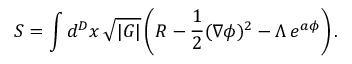<formula> <loc_0><loc_0><loc_500><loc_500>S = \int d ^ { D } x \, \sqrt { | G | } \left ( R - \frac { 1 } { 2 } ( \nabla \phi ) ^ { 2 } - \Lambda \, e ^ { a \phi } \right ) .</formula> 